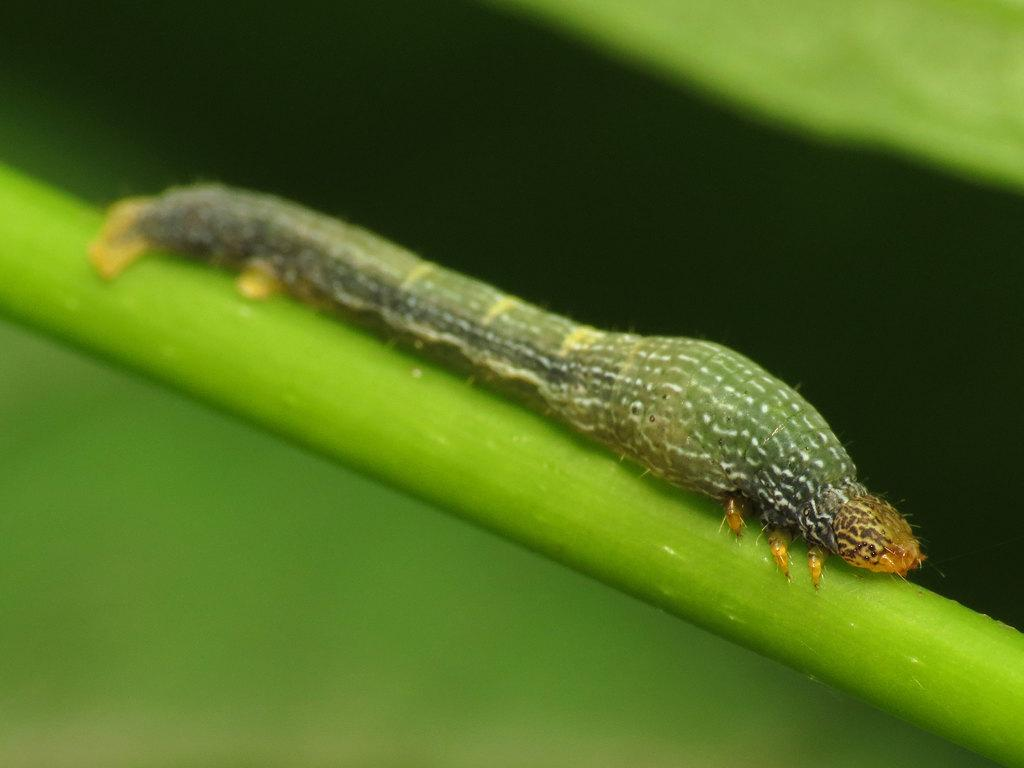What is the main subject of the image? The main subject of the image is a cankerworm on a stem. Can you describe the background of the image? The background of the image is blurred. What type of pot is visible in the image? There is no pot present in the image; it features a cankerworm on a stem with a blurred background. Can you describe the veins of the cankerworm in the image? There are no visible veins on the cankerworm in the image, as it is not a detailed close-up of the insect. 